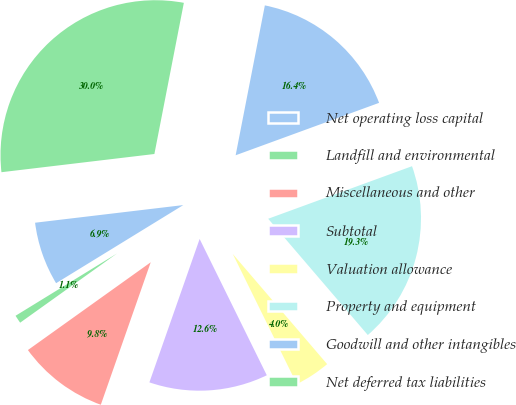Convert chart to OTSL. <chart><loc_0><loc_0><loc_500><loc_500><pie_chart><fcel>Net operating loss capital<fcel>Landfill and environmental<fcel>Miscellaneous and other<fcel>Subtotal<fcel>Valuation allowance<fcel>Property and equipment<fcel>Goodwill and other intangibles<fcel>Net deferred tax liabilities<nl><fcel>6.88%<fcel>1.11%<fcel>9.76%<fcel>12.65%<fcel>3.99%<fcel>19.3%<fcel>16.36%<fcel>29.95%<nl></chart> 